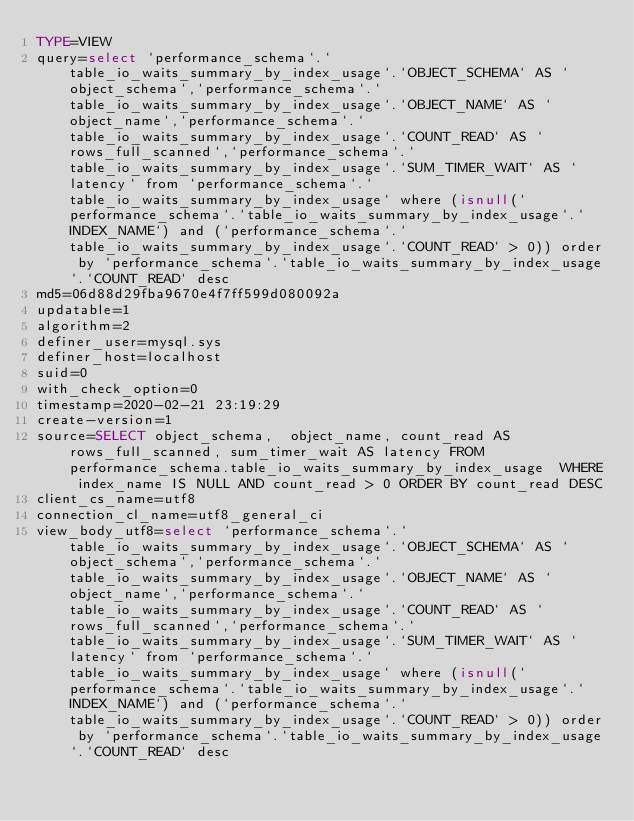Convert code to text. <code><loc_0><loc_0><loc_500><loc_500><_VisualBasic_>TYPE=VIEW
query=select `performance_schema`.`table_io_waits_summary_by_index_usage`.`OBJECT_SCHEMA` AS `object_schema`,`performance_schema`.`table_io_waits_summary_by_index_usage`.`OBJECT_NAME` AS `object_name`,`performance_schema`.`table_io_waits_summary_by_index_usage`.`COUNT_READ` AS `rows_full_scanned`,`performance_schema`.`table_io_waits_summary_by_index_usage`.`SUM_TIMER_WAIT` AS `latency` from `performance_schema`.`table_io_waits_summary_by_index_usage` where (isnull(`performance_schema`.`table_io_waits_summary_by_index_usage`.`INDEX_NAME`) and (`performance_schema`.`table_io_waits_summary_by_index_usage`.`COUNT_READ` > 0)) order by `performance_schema`.`table_io_waits_summary_by_index_usage`.`COUNT_READ` desc
md5=06d88d29fba9670e4f7ff599d080092a
updatable=1
algorithm=2
definer_user=mysql.sys
definer_host=localhost
suid=0
with_check_option=0
timestamp=2020-02-21 23:19:29
create-version=1
source=SELECT object_schema,  object_name, count_read AS rows_full_scanned, sum_timer_wait AS latency FROM performance_schema.table_io_waits_summary_by_index_usage  WHERE index_name IS NULL AND count_read > 0 ORDER BY count_read DESC
client_cs_name=utf8
connection_cl_name=utf8_general_ci
view_body_utf8=select `performance_schema`.`table_io_waits_summary_by_index_usage`.`OBJECT_SCHEMA` AS `object_schema`,`performance_schema`.`table_io_waits_summary_by_index_usage`.`OBJECT_NAME` AS `object_name`,`performance_schema`.`table_io_waits_summary_by_index_usage`.`COUNT_READ` AS `rows_full_scanned`,`performance_schema`.`table_io_waits_summary_by_index_usage`.`SUM_TIMER_WAIT` AS `latency` from `performance_schema`.`table_io_waits_summary_by_index_usage` where (isnull(`performance_schema`.`table_io_waits_summary_by_index_usage`.`INDEX_NAME`) and (`performance_schema`.`table_io_waits_summary_by_index_usage`.`COUNT_READ` > 0)) order by `performance_schema`.`table_io_waits_summary_by_index_usage`.`COUNT_READ` desc
</code> 